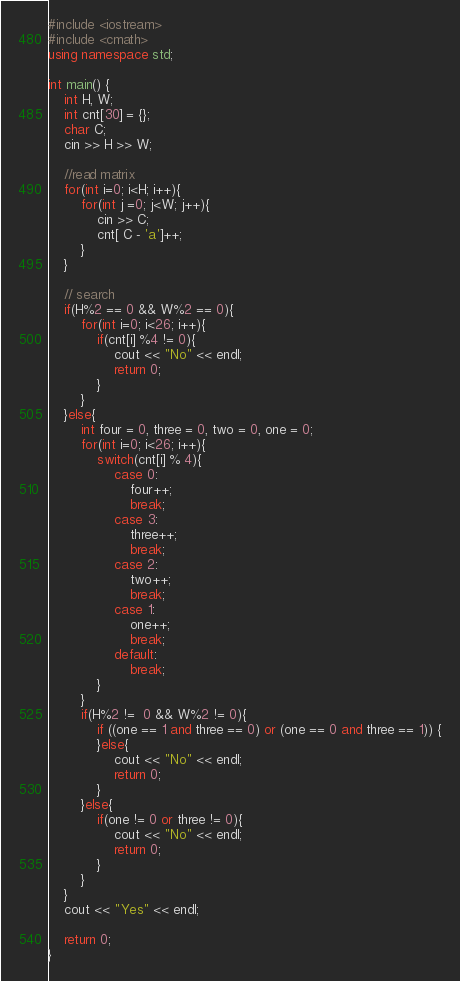<code> <loc_0><loc_0><loc_500><loc_500><_C++_>#include <iostream>
#include <cmath>
using namespace std;

int main() {
    int H, W;
    int cnt[30] = {};
    char C;
    cin >> H >> W;

    //read matrix
    for(int i=0; i<H; i++){
        for(int j =0; j<W; j++){
            cin >> C;
            cnt[ C - 'a']++;
        }
    }

    // search
    if(H%2 == 0 && W%2 == 0){
        for(int i=0; i<26; i++){
            if(cnt[i] %4 != 0){
                cout << "No" << endl;
                return 0;
            }
        }
    }else{
        int four = 0, three = 0, two = 0, one = 0;
        for(int i=0; i<26; i++){
            switch(cnt[i] % 4){
                case 0:
                    four++;
                    break;
                case 3:
                    three++;
                    break;
                case 2:
                    two++;
                    break;
                case 1:
                    one++;
                    break;
                default:
                    break;
            }
        }
        if(H%2 !=  0 && W%2 != 0){
            if ((one == 1 and three == 0) or (one == 0 and three == 1)) {
            }else{
                cout << "No" << endl;
                return 0;
            }
        }else{
            if(one != 0 or three != 0){
                cout << "No" << endl;
                return 0;
            }
        }
    }
    cout << "Yes" << endl;

    return 0;
}</code> 